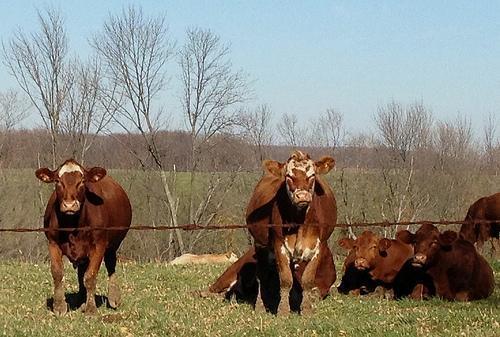How many cows are present?
Give a very brief answer. 5. 